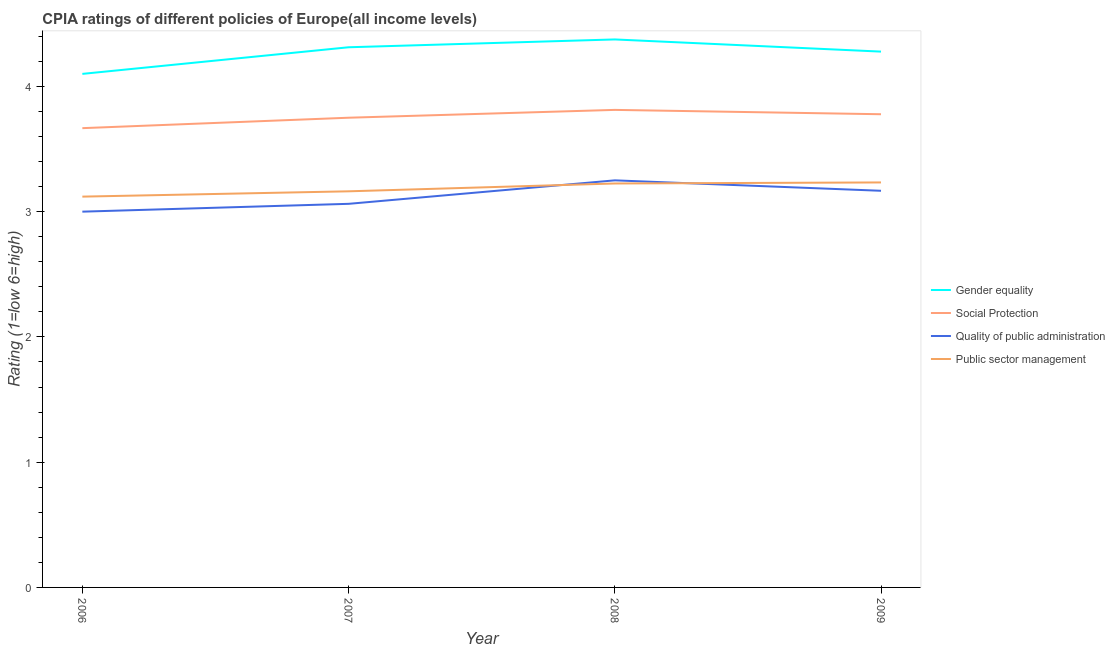How many different coloured lines are there?
Your answer should be very brief. 4. What is the cpia rating of gender equality in 2006?
Provide a succinct answer. 4.1. Across all years, what is the maximum cpia rating of quality of public administration?
Give a very brief answer. 3.25. Across all years, what is the minimum cpia rating of social protection?
Your response must be concise. 3.67. What is the total cpia rating of social protection in the graph?
Make the answer very short. 15.01. What is the difference between the cpia rating of public sector management in 2008 and that in 2009?
Give a very brief answer. -0.01. What is the average cpia rating of gender equality per year?
Ensure brevity in your answer.  4.27. In the year 2006, what is the difference between the cpia rating of social protection and cpia rating of public sector management?
Offer a terse response. 0.55. What is the ratio of the cpia rating of public sector management in 2007 to that in 2008?
Your answer should be very brief. 0.98. Is the cpia rating of gender equality in 2006 less than that in 2009?
Provide a succinct answer. Yes. Is the difference between the cpia rating of social protection in 2006 and 2008 greater than the difference between the cpia rating of public sector management in 2006 and 2008?
Your answer should be compact. No. What is the difference between the highest and the second highest cpia rating of public sector management?
Make the answer very short. 0.01. What is the difference between the highest and the lowest cpia rating of quality of public administration?
Your answer should be very brief. 0.25. Is the sum of the cpia rating of social protection in 2006 and 2008 greater than the maximum cpia rating of quality of public administration across all years?
Your answer should be compact. Yes. Is it the case that in every year, the sum of the cpia rating of gender equality and cpia rating of social protection is greater than the cpia rating of quality of public administration?
Ensure brevity in your answer.  Yes. Does the cpia rating of social protection monotonically increase over the years?
Your response must be concise. No. How many lines are there?
Offer a very short reply. 4. How many years are there in the graph?
Offer a terse response. 4. Are the values on the major ticks of Y-axis written in scientific E-notation?
Provide a short and direct response. No. Does the graph contain grids?
Make the answer very short. No. Where does the legend appear in the graph?
Ensure brevity in your answer.  Center right. How are the legend labels stacked?
Provide a short and direct response. Vertical. What is the title of the graph?
Your response must be concise. CPIA ratings of different policies of Europe(all income levels). Does "Debt policy" appear as one of the legend labels in the graph?
Offer a very short reply. No. What is the Rating (1=low 6=high) of Gender equality in 2006?
Give a very brief answer. 4.1. What is the Rating (1=low 6=high) in Social Protection in 2006?
Ensure brevity in your answer.  3.67. What is the Rating (1=low 6=high) of Quality of public administration in 2006?
Offer a terse response. 3. What is the Rating (1=low 6=high) in Public sector management in 2006?
Keep it short and to the point. 3.12. What is the Rating (1=low 6=high) of Gender equality in 2007?
Provide a succinct answer. 4.31. What is the Rating (1=low 6=high) of Social Protection in 2007?
Keep it short and to the point. 3.75. What is the Rating (1=low 6=high) in Quality of public administration in 2007?
Ensure brevity in your answer.  3.06. What is the Rating (1=low 6=high) of Public sector management in 2007?
Offer a terse response. 3.16. What is the Rating (1=low 6=high) of Gender equality in 2008?
Offer a very short reply. 4.38. What is the Rating (1=low 6=high) in Social Protection in 2008?
Your answer should be compact. 3.81. What is the Rating (1=low 6=high) in Quality of public administration in 2008?
Offer a very short reply. 3.25. What is the Rating (1=low 6=high) in Public sector management in 2008?
Keep it short and to the point. 3.23. What is the Rating (1=low 6=high) in Gender equality in 2009?
Your answer should be compact. 4.28. What is the Rating (1=low 6=high) of Social Protection in 2009?
Provide a short and direct response. 3.78. What is the Rating (1=low 6=high) in Quality of public administration in 2009?
Your response must be concise. 3.17. What is the Rating (1=low 6=high) of Public sector management in 2009?
Offer a terse response. 3.23. Across all years, what is the maximum Rating (1=low 6=high) in Gender equality?
Give a very brief answer. 4.38. Across all years, what is the maximum Rating (1=low 6=high) in Social Protection?
Provide a succinct answer. 3.81. Across all years, what is the maximum Rating (1=low 6=high) of Quality of public administration?
Ensure brevity in your answer.  3.25. Across all years, what is the maximum Rating (1=low 6=high) in Public sector management?
Offer a very short reply. 3.23. Across all years, what is the minimum Rating (1=low 6=high) of Gender equality?
Make the answer very short. 4.1. Across all years, what is the minimum Rating (1=low 6=high) of Social Protection?
Provide a short and direct response. 3.67. Across all years, what is the minimum Rating (1=low 6=high) of Quality of public administration?
Your answer should be compact. 3. Across all years, what is the minimum Rating (1=low 6=high) in Public sector management?
Provide a short and direct response. 3.12. What is the total Rating (1=low 6=high) in Gender equality in the graph?
Your response must be concise. 17.07. What is the total Rating (1=low 6=high) of Social Protection in the graph?
Give a very brief answer. 15.01. What is the total Rating (1=low 6=high) in Quality of public administration in the graph?
Provide a succinct answer. 12.48. What is the total Rating (1=low 6=high) of Public sector management in the graph?
Give a very brief answer. 12.74. What is the difference between the Rating (1=low 6=high) in Gender equality in 2006 and that in 2007?
Ensure brevity in your answer.  -0.21. What is the difference between the Rating (1=low 6=high) in Social Protection in 2006 and that in 2007?
Ensure brevity in your answer.  -0.08. What is the difference between the Rating (1=low 6=high) of Quality of public administration in 2006 and that in 2007?
Your answer should be very brief. -0.06. What is the difference between the Rating (1=low 6=high) in Public sector management in 2006 and that in 2007?
Make the answer very short. -0.04. What is the difference between the Rating (1=low 6=high) in Gender equality in 2006 and that in 2008?
Your answer should be compact. -0.28. What is the difference between the Rating (1=low 6=high) in Social Protection in 2006 and that in 2008?
Your answer should be very brief. -0.15. What is the difference between the Rating (1=low 6=high) in Quality of public administration in 2006 and that in 2008?
Your response must be concise. -0.25. What is the difference between the Rating (1=low 6=high) of Public sector management in 2006 and that in 2008?
Keep it short and to the point. -0.1. What is the difference between the Rating (1=low 6=high) in Gender equality in 2006 and that in 2009?
Provide a succinct answer. -0.18. What is the difference between the Rating (1=low 6=high) of Social Protection in 2006 and that in 2009?
Give a very brief answer. -0.11. What is the difference between the Rating (1=low 6=high) of Quality of public administration in 2006 and that in 2009?
Provide a short and direct response. -0.17. What is the difference between the Rating (1=low 6=high) of Public sector management in 2006 and that in 2009?
Offer a very short reply. -0.11. What is the difference between the Rating (1=low 6=high) of Gender equality in 2007 and that in 2008?
Ensure brevity in your answer.  -0.06. What is the difference between the Rating (1=low 6=high) in Social Protection in 2007 and that in 2008?
Your answer should be compact. -0.06. What is the difference between the Rating (1=low 6=high) of Quality of public administration in 2007 and that in 2008?
Your response must be concise. -0.19. What is the difference between the Rating (1=low 6=high) in Public sector management in 2007 and that in 2008?
Provide a short and direct response. -0.06. What is the difference between the Rating (1=low 6=high) of Gender equality in 2007 and that in 2009?
Your response must be concise. 0.03. What is the difference between the Rating (1=low 6=high) in Social Protection in 2007 and that in 2009?
Your answer should be very brief. -0.03. What is the difference between the Rating (1=low 6=high) in Quality of public administration in 2007 and that in 2009?
Your answer should be compact. -0.1. What is the difference between the Rating (1=low 6=high) of Public sector management in 2007 and that in 2009?
Give a very brief answer. -0.07. What is the difference between the Rating (1=low 6=high) of Gender equality in 2008 and that in 2009?
Provide a short and direct response. 0.1. What is the difference between the Rating (1=low 6=high) in Social Protection in 2008 and that in 2009?
Your answer should be very brief. 0.03. What is the difference between the Rating (1=low 6=high) of Quality of public administration in 2008 and that in 2009?
Your response must be concise. 0.08. What is the difference between the Rating (1=low 6=high) of Public sector management in 2008 and that in 2009?
Give a very brief answer. -0.01. What is the difference between the Rating (1=low 6=high) in Gender equality in 2006 and the Rating (1=low 6=high) in Quality of public administration in 2007?
Your answer should be very brief. 1.04. What is the difference between the Rating (1=low 6=high) in Gender equality in 2006 and the Rating (1=low 6=high) in Public sector management in 2007?
Offer a terse response. 0.94. What is the difference between the Rating (1=low 6=high) of Social Protection in 2006 and the Rating (1=low 6=high) of Quality of public administration in 2007?
Provide a short and direct response. 0.6. What is the difference between the Rating (1=low 6=high) of Social Protection in 2006 and the Rating (1=low 6=high) of Public sector management in 2007?
Your answer should be very brief. 0.5. What is the difference between the Rating (1=low 6=high) of Quality of public administration in 2006 and the Rating (1=low 6=high) of Public sector management in 2007?
Offer a terse response. -0.16. What is the difference between the Rating (1=low 6=high) of Gender equality in 2006 and the Rating (1=low 6=high) of Social Protection in 2008?
Keep it short and to the point. 0.29. What is the difference between the Rating (1=low 6=high) in Social Protection in 2006 and the Rating (1=low 6=high) in Quality of public administration in 2008?
Your answer should be very brief. 0.42. What is the difference between the Rating (1=low 6=high) of Social Protection in 2006 and the Rating (1=low 6=high) of Public sector management in 2008?
Ensure brevity in your answer.  0.44. What is the difference between the Rating (1=low 6=high) of Quality of public administration in 2006 and the Rating (1=low 6=high) of Public sector management in 2008?
Your answer should be very brief. -0.23. What is the difference between the Rating (1=low 6=high) of Gender equality in 2006 and the Rating (1=low 6=high) of Social Protection in 2009?
Give a very brief answer. 0.32. What is the difference between the Rating (1=low 6=high) of Gender equality in 2006 and the Rating (1=low 6=high) of Public sector management in 2009?
Your answer should be compact. 0.87. What is the difference between the Rating (1=low 6=high) of Social Protection in 2006 and the Rating (1=low 6=high) of Quality of public administration in 2009?
Your answer should be very brief. 0.5. What is the difference between the Rating (1=low 6=high) in Social Protection in 2006 and the Rating (1=low 6=high) in Public sector management in 2009?
Provide a succinct answer. 0.43. What is the difference between the Rating (1=low 6=high) in Quality of public administration in 2006 and the Rating (1=low 6=high) in Public sector management in 2009?
Ensure brevity in your answer.  -0.23. What is the difference between the Rating (1=low 6=high) of Gender equality in 2007 and the Rating (1=low 6=high) of Public sector management in 2008?
Make the answer very short. 1.09. What is the difference between the Rating (1=low 6=high) of Social Protection in 2007 and the Rating (1=low 6=high) of Quality of public administration in 2008?
Offer a very short reply. 0.5. What is the difference between the Rating (1=low 6=high) in Social Protection in 2007 and the Rating (1=low 6=high) in Public sector management in 2008?
Your answer should be compact. 0.53. What is the difference between the Rating (1=low 6=high) of Quality of public administration in 2007 and the Rating (1=low 6=high) of Public sector management in 2008?
Your response must be concise. -0.16. What is the difference between the Rating (1=low 6=high) in Gender equality in 2007 and the Rating (1=low 6=high) in Social Protection in 2009?
Provide a succinct answer. 0.53. What is the difference between the Rating (1=low 6=high) in Gender equality in 2007 and the Rating (1=low 6=high) in Quality of public administration in 2009?
Give a very brief answer. 1.15. What is the difference between the Rating (1=low 6=high) of Gender equality in 2007 and the Rating (1=low 6=high) of Public sector management in 2009?
Keep it short and to the point. 1.08. What is the difference between the Rating (1=low 6=high) of Social Protection in 2007 and the Rating (1=low 6=high) of Quality of public administration in 2009?
Offer a very short reply. 0.58. What is the difference between the Rating (1=low 6=high) in Social Protection in 2007 and the Rating (1=low 6=high) in Public sector management in 2009?
Give a very brief answer. 0.52. What is the difference between the Rating (1=low 6=high) of Quality of public administration in 2007 and the Rating (1=low 6=high) of Public sector management in 2009?
Your answer should be compact. -0.17. What is the difference between the Rating (1=low 6=high) in Gender equality in 2008 and the Rating (1=low 6=high) in Social Protection in 2009?
Give a very brief answer. 0.6. What is the difference between the Rating (1=low 6=high) in Gender equality in 2008 and the Rating (1=low 6=high) in Quality of public administration in 2009?
Give a very brief answer. 1.21. What is the difference between the Rating (1=low 6=high) in Gender equality in 2008 and the Rating (1=low 6=high) in Public sector management in 2009?
Keep it short and to the point. 1.14. What is the difference between the Rating (1=low 6=high) of Social Protection in 2008 and the Rating (1=low 6=high) of Quality of public administration in 2009?
Your answer should be very brief. 0.65. What is the difference between the Rating (1=low 6=high) of Social Protection in 2008 and the Rating (1=low 6=high) of Public sector management in 2009?
Keep it short and to the point. 0.58. What is the difference between the Rating (1=low 6=high) of Quality of public administration in 2008 and the Rating (1=low 6=high) of Public sector management in 2009?
Keep it short and to the point. 0.02. What is the average Rating (1=low 6=high) in Gender equality per year?
Ensure brevity in your answer.  4.27. What is the average Rating (1=low 6=high) of Social Protection per year?
Give a very brief answer. 3.75. What is the average Rating (1=low 6=high) in Quality of public administration per year?
Provide a succinct answer. 3.12. What is the average Rating (1=low 6=high) of Public sector management per year?
Your response must be concise. 3.19. In the year 2006, what is the difference between the Rating (1=low 6=high) in Gender equality and Rating (1=low 6=high) in Social Protection?
Your response must be concise. 0.43. In the year 2006, what is the difference between the Rating (1=low 6=high) of Gender equality and Rating (1=low 6=high) of Public sector management?
Your answer should be very brief. 0.98. In the year 2006, what is the difference between the Rating (1=low 6=high) of Social Protection and Rating (1=low 6=high) of Quality of public administration?
Your answer should be very brief. 0.67. In the year 2006, what is the difference between the Rating (1=low 6=high) in Social Protection and Rating (1=low 6=high) in Public sector management?
Make the answer very short. 0.55. In the year 2006, what is the difference between the Rating (1=low 6=high) in Quality of public administration and Rating (1=low 6=high) in Public sector management?
Ensure brevity in your answer.  -0.12. In the year 2007, what is the difference between the Rating (1=low 6=high) in Gender equality and Rating (1=low 6=high) in Social Protection?
Your answer should be compact. 0.56. In the year 2007, what is the difference between the Rating (1=low 6=high) in Gender equality and Rating (1=low 6=high) in Quality of public administration?
Your answer should be compact. 1.25. In the year 2007, what is the difference between the Rating (1=low 6=high) in Gender equality and Rating (1=low 6=high) in Public sector management?
Ensure brevity in your answer.  1.15. In the year 2007, what is the difference between the Rating (1=low 6=high) in Social Protection and Rating (1=low 6=high) in Quality of public administration?
Provide a succinct answer. 0.69. In the year 2007, what is the difference between the Rating (1=low 6=high) of Social Protection and Rating (1=low 6=high) of Public sector management?
Ensure brevity in your answer.  0.59. In the year 2007, what is the difference between the Rating (1=low 6=high) of Quality of public administration and Rating (1=low 6=high) of Public sector management?
Make the answer very short. -0.1. In the year 2008, what is the difference between the Rating (1=low 6=high) in Gender equality and Rating (1=low 6=high) in Social Protection?
Ensure brevity in your answer.  0.56. In the year 2008, what is the difference between the Rating (1=low 6=high) in Gender equality and Rating (1=low 6=high) in Public sector management?
Your answer should be very brief. 1.15. In the year 2008, what is the difference between the Rating (1=low 6=high) of Social Protection and Rating (1=low 6=high) of Quality of public administration?
Offer a very short reply. 0.56. In the year 2008, what is the difference between the Rating (1=low 6=high) in Social Protection and Rating (1=low 6=high) in Public sector management?
Make the answer very short. 0.59. In the year 2008, what is the difference between the Rating (1=low 6=high) of Quality of public administration and Rating (1=low 6=high) of Public sector management?
Your answer should be compact. 0.03. In the year 2009, what is the difference between the Rating (1=low 6=high) of Gender equality and Rating (1=low 6=high) of Social Protection?
Your answer should be very brief. 0.5. In the year 2009, what is the difference between the Rating (1=low 6=high) of Gender equality and Rating (1=low 6=high) of Quality of public administration?
Keep it short and to the point. 1.11. In the year 2009, what is the difference between the Rating (1=low 6=high) of Gender equality and Rating (1=low 6=high) of Public sector management?
Give a very brief answer. 1.04. In the year 2009, what is the difference between the Rating (1=low 6=high) in Social Protection and Rating (1=low 6=high) in Quality of public administration?
Your answer should be very brief. 0.61. In the year 2009, what is the difference between the Rating (1=low 6=high) of Social Protection and Rating (1=low 6=high) of Public sector management?
Offer a terse response. 0.54. In the year 2009, what is the difference between the Rating (1=low 6=high) in Quality of public administration and Rating (1=low 6=high) in Public sector management?
Keep it short and to the point. -0.07. What is the ratio of the Rating (1=low 6=high) in Gender equality in 2006 to that in 2007?
Provide a short and direct response. 0.95. What is the ratio of the Rating (1=low 6=high) of Social Protection in 2006 to that in 2007?
Offer a very short reply. 0.98. What is the ratio of the Rating (1=low 6=high) of Quality of public administration in 2006 to that in 2007?
Your answer should be very brief. 0.98. What is the ratio of the Rating (1=low 6=high) of Public sector management in 2006 to that in 2007?
Offer a very short reply. 0.99. What is the ratio of the Rating (1=low 6=high) of Gender equality in 2006 to that in 2008?
Your answer should be compact. 0.94. What is the ratio of the Rating (1=low 6=high) of Social Protection in 2006 to that in 2008?
Your response must be concise. 0.96. What is the ratio of the Rating (1=low 6=high) of Public sector management in 2006 to that in 2008?
Ensure brevity in your answer.  0.97. What is the ratio of the Rating (1=low 6=high) of Gender equality in 2006 to that in 2009?
Ensure brevity in your answer.  0.96. What is the ratio of the Rating (1=low 6=high) in Social Protection in 2006 to that in 2009?
Offer a very short reply. 0.97. What is the ratio of the Rating (1=low 6=high) of Public sector management in 2006 to that in 2009?
Your answer should be compact. 0.96. What is the ratio of the Rating (1=low 6=high) in Gender equality in 2007 to that in 2008?
Your answer should be very brief. 0.99. What is the ratio of the Rating (1=low 6=high) of Social Protection in 2007 to that in 2008?
Make the answer very short. 0.98. What is the ratio of the Rating (1=low 6=high) of Quality of public administration in 2007 to that in 2008?
Provide a succinct answer. 0.94. What is the ratio of the Rating (1=low 6=high) in Public sector management in 2007 to that in 2008?
Give a very brief answer. 0.98. What is the ratio of the Rating (1=low 6=high) of Quality of public administration in 2007 to that in 2009?
Offer a terse response. 0.97. What is the ratio of the Rating (1=low 6=high) of Public sector management in 2007 to that in 2009?
Keep it short and to the point. 0.98. What is the ratio of the Rating (1=low 6=high) of Gender equality in 2008 to that in 2009?
Your answer should be very brief. 1.02. What is the ratio of the Rating (1=low 6=high) in Social Protection in 2008 to that in 2009?
Provide a short and direct response. 1.01. What is the ratio of the Rating (1=low 6=high) in Quality of public administration in 2008 to that in 2009?
Provide a succinct answer. 1.03. What is the ratio of the Rating (1=low 6=high) of Public sector management in 2008 to that in 2009?
Your answer should be compact. 1. What is the difference between the highest and the second highest Rating (1=low 6=high) of Gender equality?
Ensure brevity in your answer.  0.06. What is the difference between the highest and the second highest Rating (1=low 6=high) in Social Protection?
Your response must be concise. 0.03. What is the difference between the highest and the second highest Rating (1=low 6=high) of Quality of public administration?
Offer a very short reply. 0.08. What is the difference between the highest and the second highest Rating (1=low 6=high) of Public sector management?
Ensure brevity in your answer.  0.01. What is the difference between the highest and the lowest Rating (1=low 6=high) in Gender equality?
Make the answer very short. 0.28. What is the difference between the highest and the lowest Rating (1=low 6=high) in Social Protection?
Offer a terse response. 0.15. What is the difference between the highest and the lowest Rating (1=low 6=high) in Quality of public administration?
Ensure brevity in your answer.  0.25. What is the difference between the highest and the lowest Rating (1=low 6=high) in Public sector management?
Ensure brevity in your answer.  0.11. 